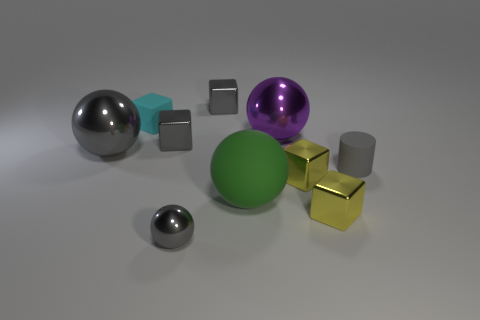Subtract all small gray shiny blocks. How many blocks are left? 3 Subtract all purple cylinders. How many gray cubes are left? 2 Subtract 2 blocks. How many blocks are left? 3 Subtract all gray spheres. How many spheres are left? 2 Subtract all gray blocks. Subtract all blue cylinders. How many blocks are left? 3 Subtract all balls. How many objects are left? 6 Subtract all big rubber spheres. Subtract all big gray objects. How many objects are left? 8 Add 1 cubes. How many cubes are left? 6 Add 6 big purple metallic spheres. How many big purple metallic spheres exist? 7 Subtract 2 gray balls. How many objects are left? 8 